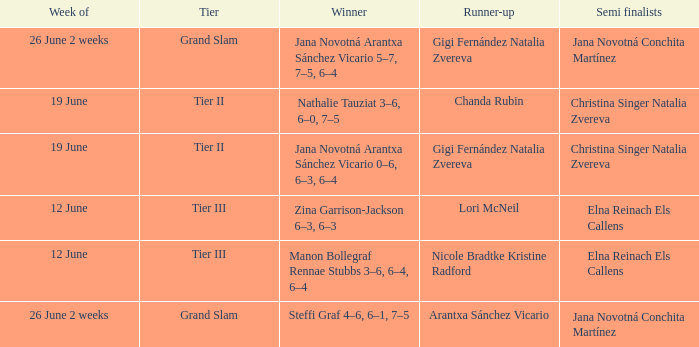When the Tier is listed as tier iii, who is the Winner? Zina Garrison-Jackson 6–3, 6–3, Manon Bollegraf Rennae Stubbs 3–6, 6–4, 6–4. 